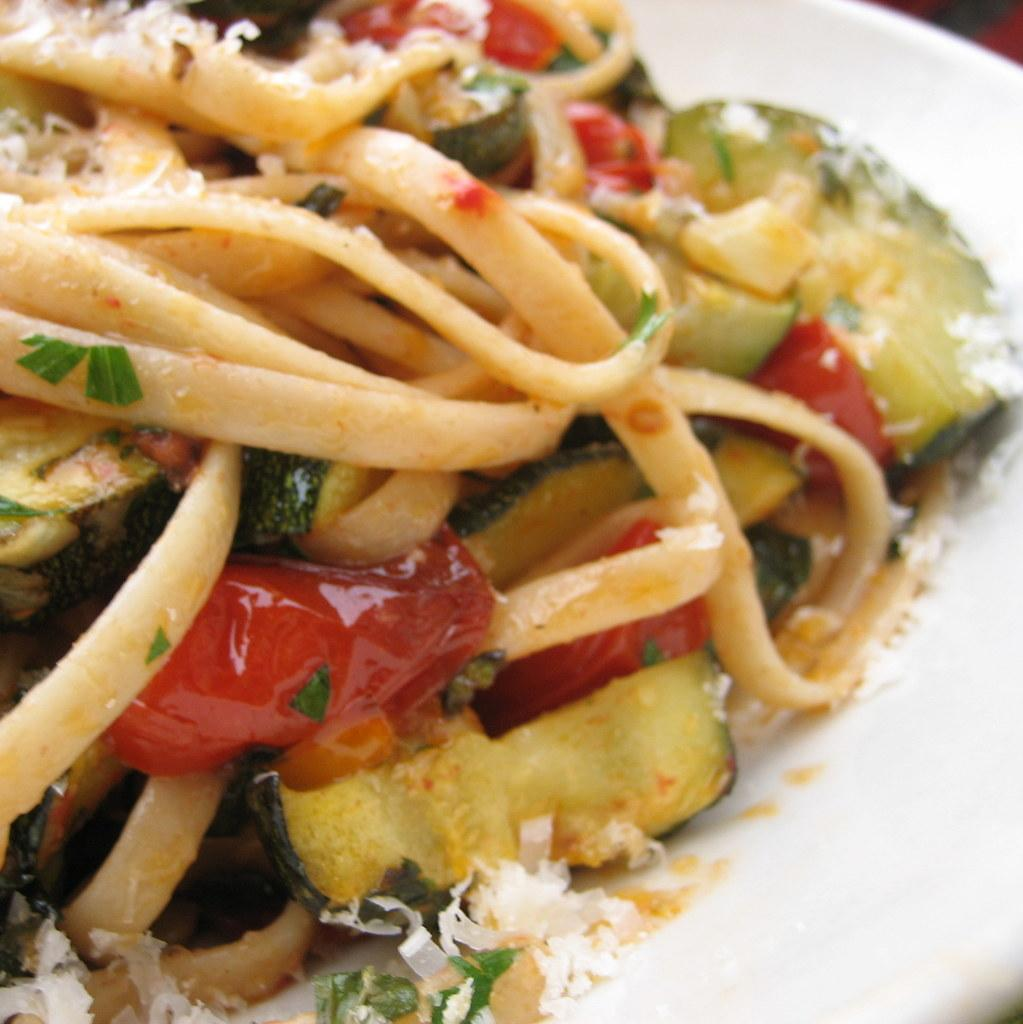What is on the plate that is visible in the image? There is a white plate in the image, and there are food items on the plate. What else can be seen on the plate besides the food items? There are ingredients on the plate. What type of advice can be seen written on the plate in the image? There is no advice written on the plate in the image; it only contains food items and ingredients. 